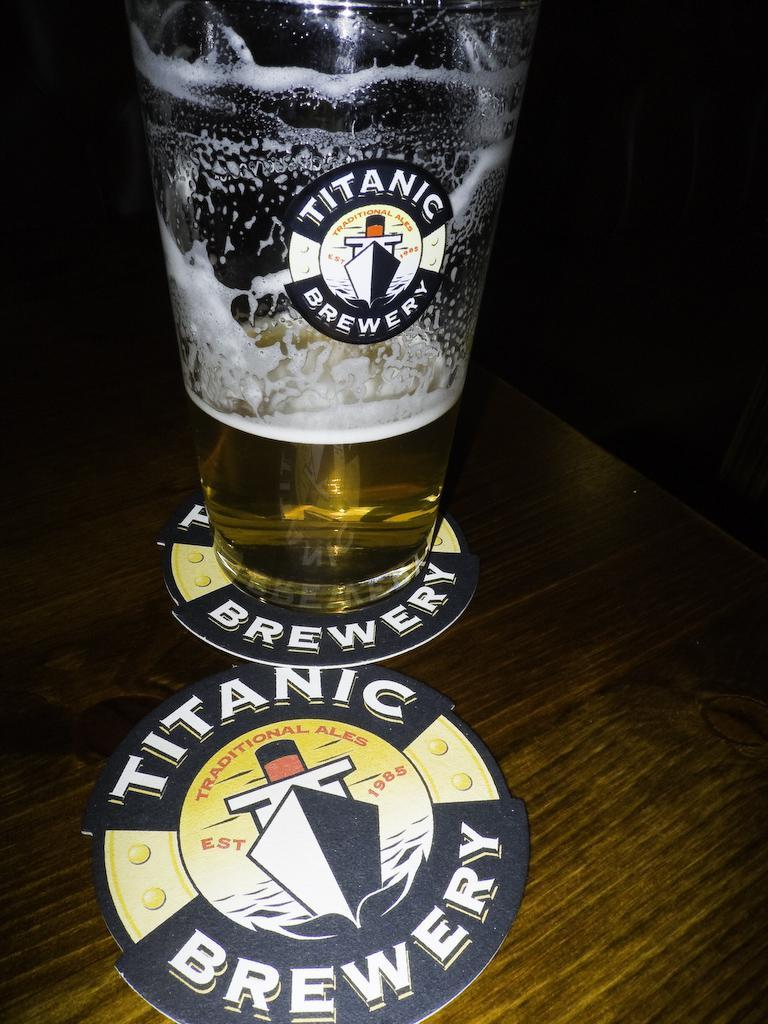<image>
Relay a brief, clear account of the picture shown. a coaster that says titanic brewery on it and a bottle of titanic brewery beer 